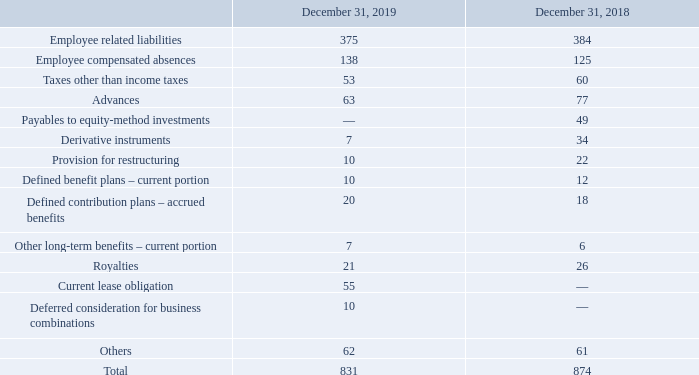Other payables and accrued liabilities consisted of the following:
Derivative instruments are further described in Note 27.
As of December 31, 2019, payables to equity-method investments was nil compared to $49 million as of December 31, 2018, as a result of the wind-down of the joint venture with Ericsson.
On January 1, 2019, the Company adopted the new guidance on lease accounting and the current portion of the lease obligation is now included in other payables and accrued liabilities. The impact of the adoption of this new guidance is further described in Note 11.
Other payables and accrued liabilities also include individually insignificant amounts as of December 31, 2019 and December 31, 2018, presented cumulatively in line “Others”.
How much was the payables to equity-method investments as of December 31, 2018? $49 million. What was the new guideline adopted by the company on January 1, 2019? On january 1, 2019, the company adopted the new guidance on lease accounting and the current portion of the lease obligation is now included in other payables and accrued liabilities. How much was the  payables to equity-method investments as of December 31, 2019? Nil. What is the average Employee related liabilities?
Answer scale should be: million. (375+384) / 2
Answer: 379.5. What is the average Employee compensated absences?
Answer scale should be: million. (138+125) / 2 
Answer: 131.5. What is the average Taxes other than income taxes?
Answer scale should be: million. (53+60) / 2
Answer: 56.5. 